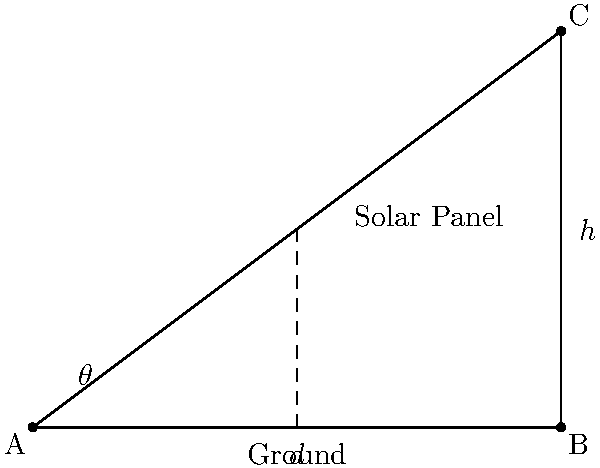An insurance company is installing solar panels on its new eco-friendly office building. The optimal angle for the solar panels depends on the building's latitude. If the building is 75 meters tall and the solar panels need to extend 100 meters from the base of the building, what is the optimal angle $\theta$ (in degrees) for the solar panels to maximize energy capture? To solve this problem, we'll use trigonometry:

1. We have a right triangle with the following known dimensions:
   - The height (h) is 75 meters
   - The distance from the base (d) is 100 meters

2. We need to find the angle $\theta$ between the ground and the solar panel.

3. In a right triangle, we can use the tangent function to find this angle:

   $$\tan(\theta) = \frac{\text{opposite}}{\text{adjacent}} = \frac{h}{d} = \frac{75}{100}$$

4. To find $\theta$, we need to use the inverse tangent (arctan or $\tan^{-1}$) function:

   $$\theta = \tan^{-1}(\frac{75}{100})$$

5. Using a calculator or computer:

   $$\theta \approx 36.87\text{ degrees}$$

6. Rounding to the nearest degree:

   $$\theta \approx 37\text{ degrees}$$

This angle represents the optimal tilt for the solar panels to maximize energy capture based on the building's dimensions.
Answer: 37 degrees 